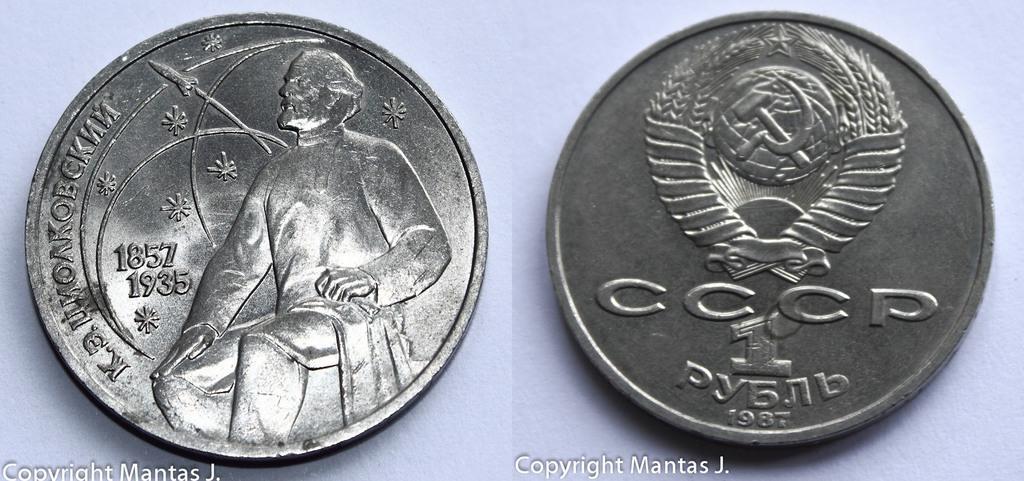How would you summarize this image in a sentence or two? This picture is the collage of two images. There are two coins in this picture. 